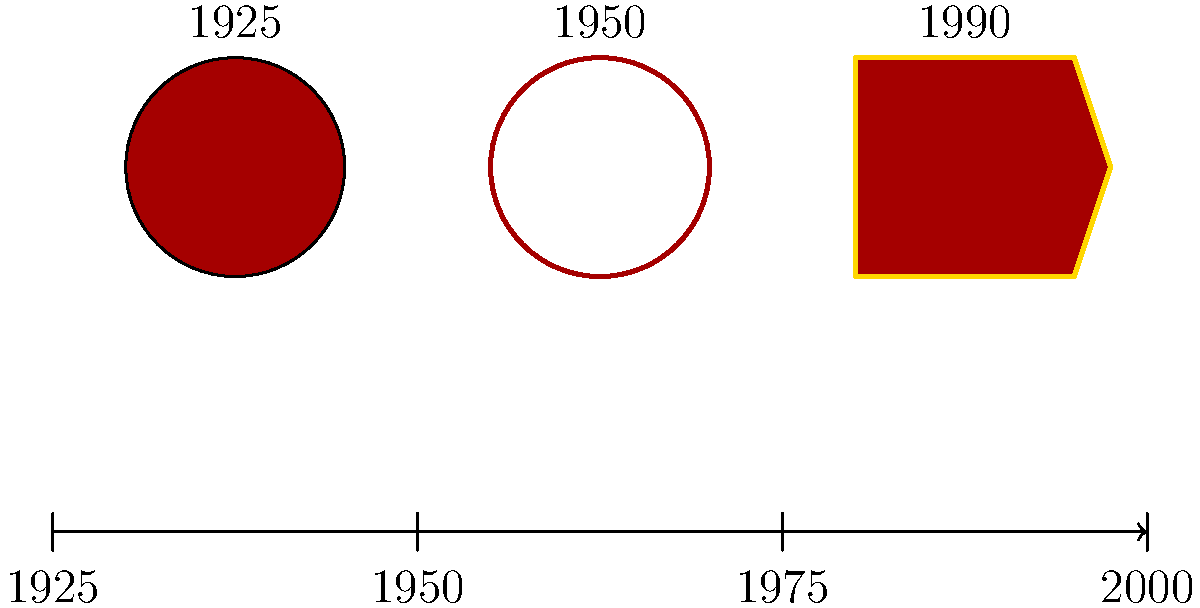Based on the timeline of Memorial University's logo evolution shown above, which decade marked a significant shift from the circular design to a shield-shaped emblem? To answer this question, we need to analyze the visual representation of Memorial University's logo evolution:

1. The timeline spans from 1925 to 2000, with 25-year intervals marked.

2. We can see three distinct logo designs:
   a. 1925: A simple circular design in red.
   b. 1950: A more detailed circular seal with a white background and red outline.
   c. 1990: A shield-shaped emblem in red with a gold outline.

3. The question asks about the shift from circular to shield-shaped design.

4. Observing the timeline, we can see that this shift occurred between the second (1950) and third (1990) logos.

5. The decade that falls between these two points is the 1980s.

Therefore, the significant shift from the circular design to the shield-shaped emblem occurred in the 1980s, as represented by the change between the 1950 and 1990 logos on the timeline.
Answer: 1980s 